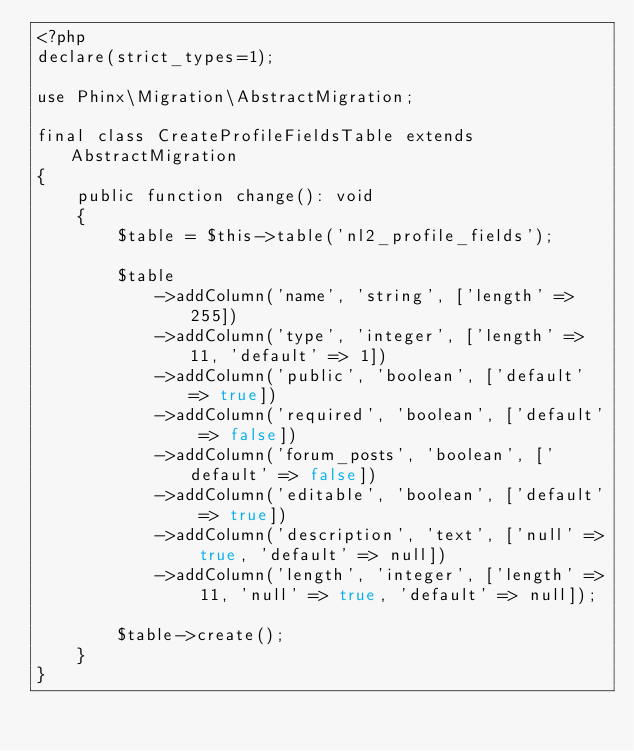<code> <loc_0><loc_0><loc_500><loc_500><_PHP_><?php
declare(strict_types=1);

use Phinx\Migration\AbstractMigration;

final class CreateProfileFieldsTable extends AbstractMigration
{
    public function change(): void
    {
        $table = $this->table('nl2_profile_fields');

        $table
            ->addColumn('name', 'string', ['length' => 255])
            ->addColumn('type', 'integer', ['length' => 11, 'default' => 1])
            ->addColumn('public', 'boolean', ['default' => true])
            ->addColumn('required', 'boolean', ['default' => false])
            ->addColumn('forum_posts', 'boolean', ['default' => false])
            ->addColumn('editable', 'boolean', ['default' => true])
            ->addColumn('description', 'text', ['null' => true, 'default' => null])
            ->addColumn('length', 'integer', ['length' => 11, 'null' => true, 'default' => null]);

        $table->create();
    }
}
</code> 